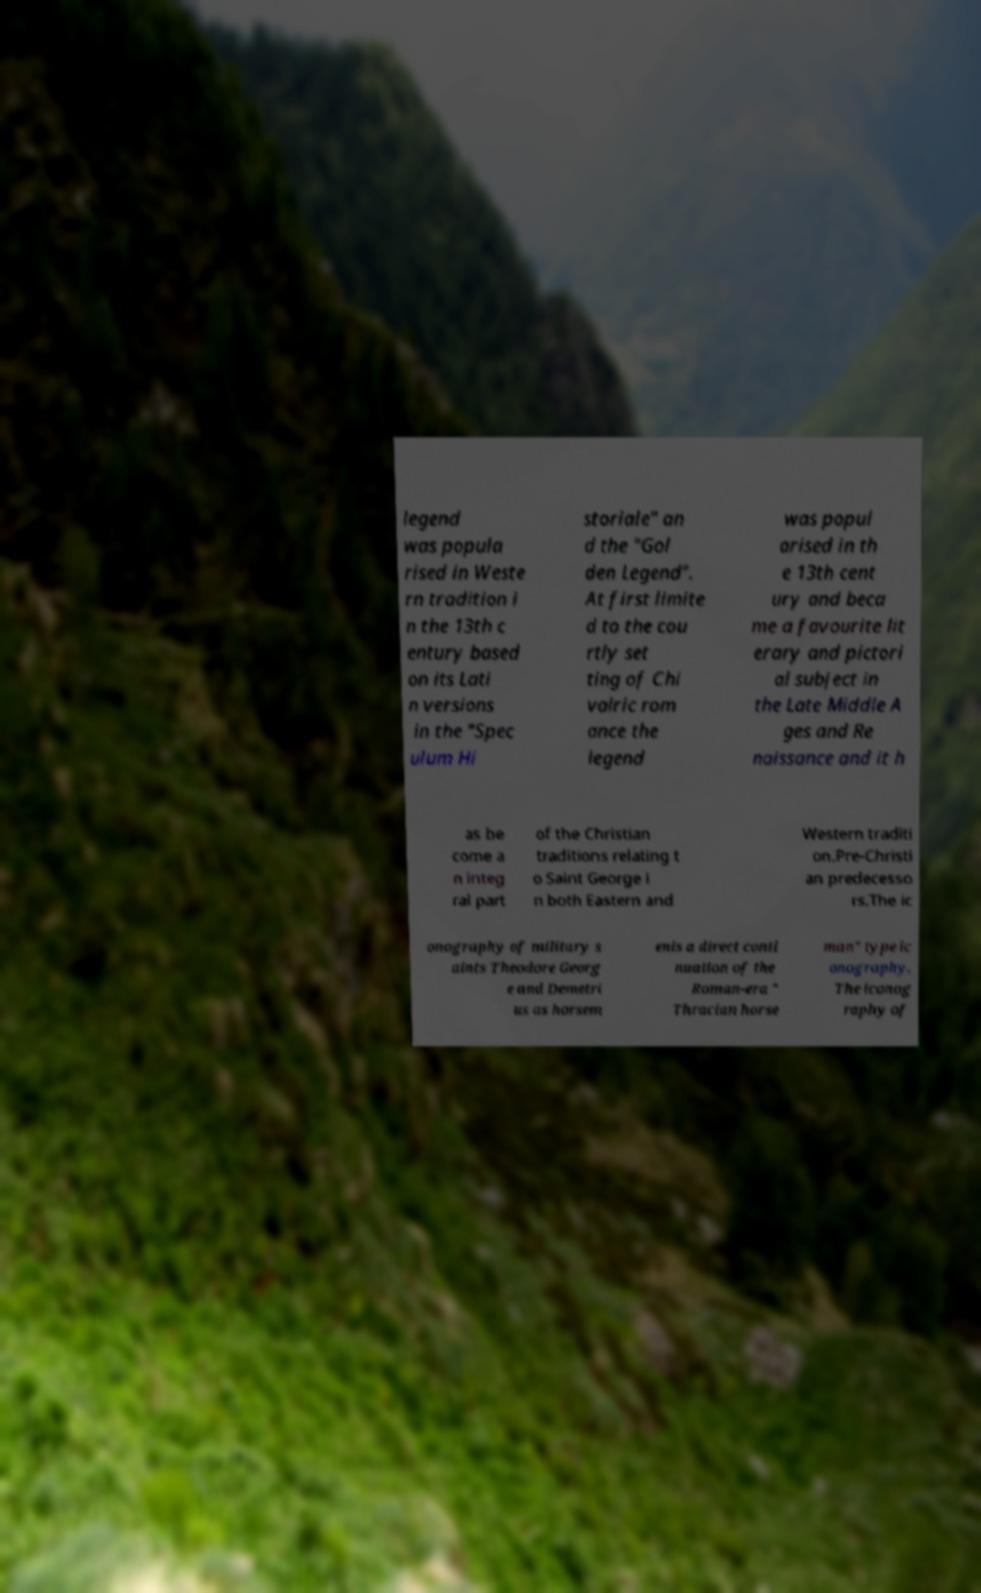Could you assist in decoding the text presented in this image and type it out clearly? legend was popula rised in Weste rn tradition i n the 13th c entury based on its Lati n versions in the "Spec ulum Hi storiale" an d the "Gol den Legend". At first limite d to the cou rtly set ting of Chi valric rom ance the legend was popul arised in th e 13th cent ury and beca me a favourite lit erary and pictori al subject in the Late Middle A ges and Re naissance and it h as be come a n integ ral part of the Christian traditions relating t o Saint George i n both Eastern and Western traditi on.Pre-Christi an predecesso rs.The ic onography of military s aints Theodore Georg e and Demetri us as horsem enis a direct conti nuation of the Roman-era " Thracian horse man" type ic onography. The iconog raphy of 